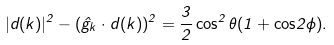Convert formula to latex. <formula><loc_0><loc_0><loc_500><loc_500>| d ( k ) | ^ { 2 } - ( \hat { g } _ { k } \cdot d ( k ) ) ^ { 2 } = \frac { 3 } { 2 } \cos ^ { 2 } \theta ( 1 + { \cos } 2 \phi ) .</formula> 